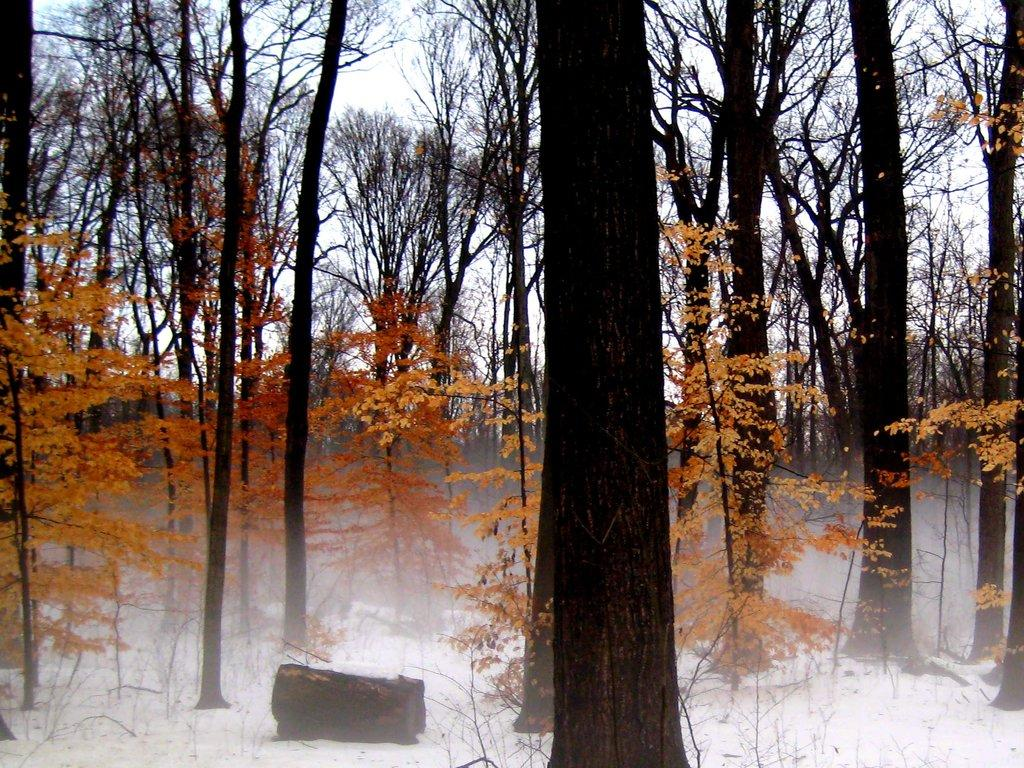What type of weather is depicted in the image? There is snow at the bottom of the image, indicating a winter scene. What can be seen in the middle of the image? There are trees in the middle of the image. What is visible at the top of the image? The sky is visible at the top of the image. Can you tell me how many sisters are involved in the fight in the image? There is no fight or sisters present in the image; it features snow, trees, and a sky. 